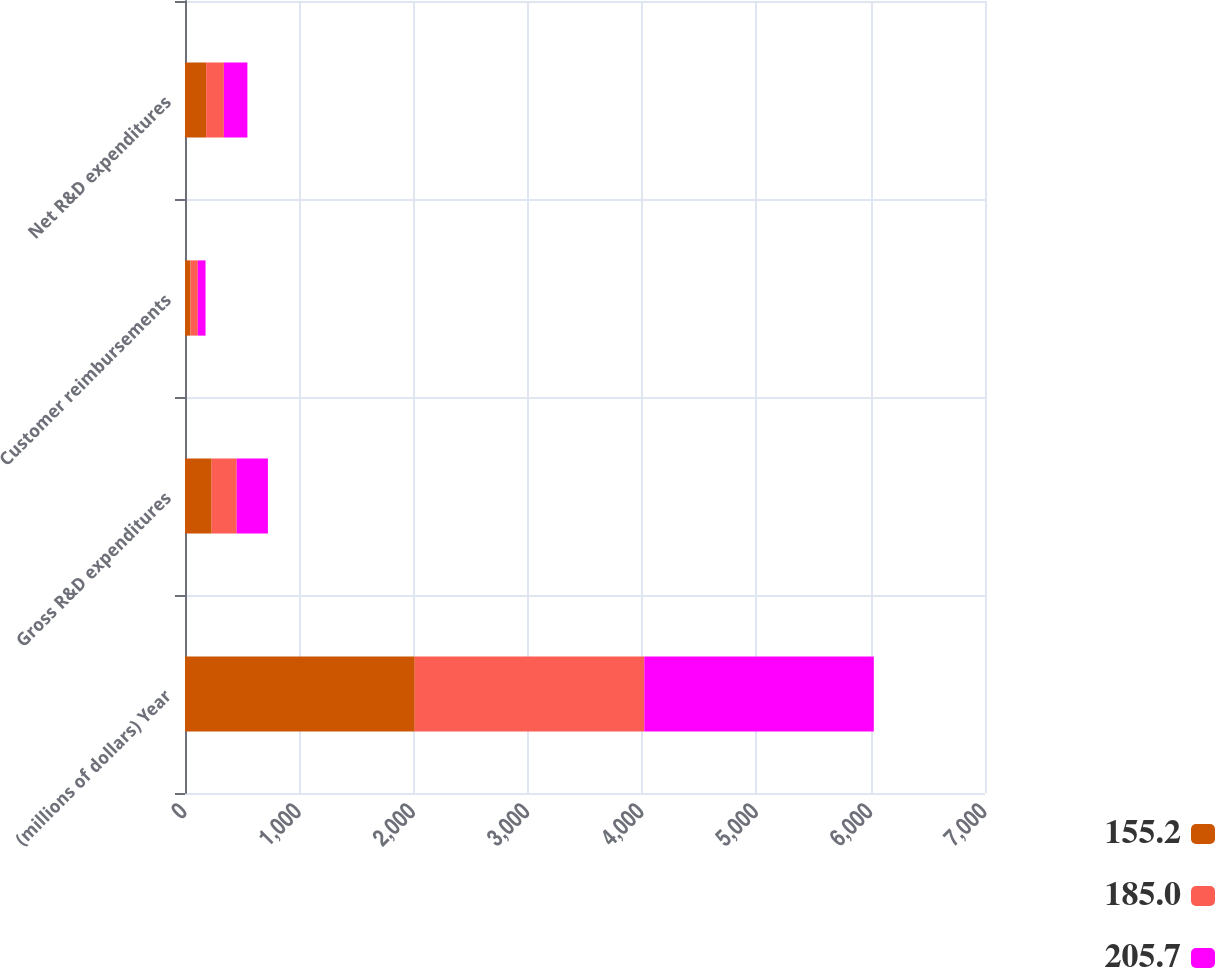Convert chart. <chart><loc_0><loc_0><loc_500><loc_500><stacked_bar_chart><ecel><fcel>(millions of dollars) Year<fcel>Gross R&D expenditures<fcel>Customer reimbursements<fcel>Net R&D expenditures<nl><fcel>155.2<fcel>2010<fcel>233.2<fcel>48.2<fcel>185<nl><fcel>185<fcel>2009<fcel>219<fcel>63.8<fcel>155.2<nl><fcel>205.7<fcel>2008<fcel>273.4<fcel>67.7<fcel>205.7<nl></chart> 